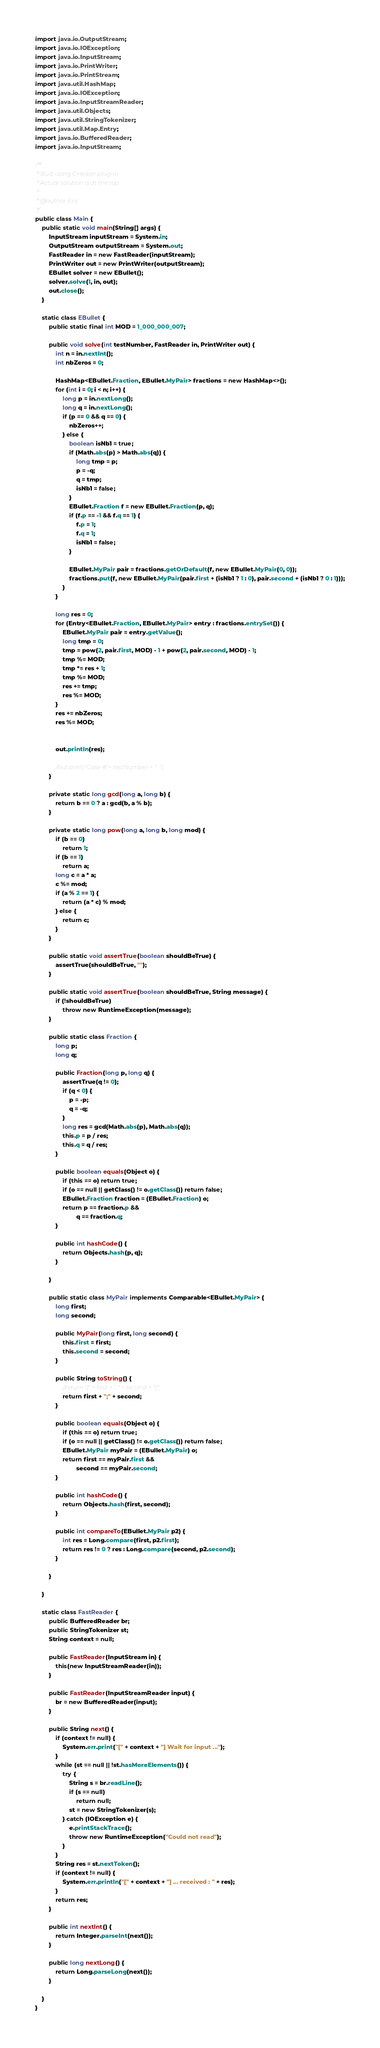<code> <loc_0><loc_0><loc_500><loc_500><_Java_>import java.io.OutputStream;
import java.io.IOException;
import java.io.InputStream;
import java.io.PrintWriter;
import java.io.PrintStream;
import java.util.HashMap;
import java.io.IOException;
import java.io.InputStreamReader;
import java.util.Objects;
import java.util.StringTokenizer;
import java.util.Map.Entry;
import java.io.BufferedReader;
import java.io.InputStream;

/**
 * Built using CHelper plug-in
 * Actual solution is at the top
 *
 * @author Eric
 */
public class Main {
    public static void main(String[] args) {
        InputStream inputStream = System.in;
        OutputStream outputStream = System.out;
        FastReader in = new FastReader(inputStream);
        PrintWriter out = new PrintWriter(outputStream);
        EBullet solver = new EBullet();
        solver.solve(1, in, out);
        out.close();
    }

    static class EBullet {
        public static final int MOD = 1_000_000_007;

        public void solve(int testNumber, FastReader in, PrintWriter out) {
            int n = in.nextInt();
            int nbZeros = 0;

            HashMap<EBullet.Fraction, EBullet.MyPair> fractions = new HashMap<>();
            for (int i = 0; i < n; i++) {
                long p = in.nextLong();
                long q = in.nextLong();
                if (p == 0 && q == 0) {
                    nbZeros++;
                } else {
                    boolean isNb1 = true;
                    if (Math.abs(p) > Math.abs(q)) {
                        long tmp = p;
                        p = -q;
                        q = tmp;
                        isNb1 = false;
                    }
                    EBullet.Fraction f = new EBullet.Fraction(p, q);
                    if (f.p == -1 && f.q == 1) {
                        f.p = 1;
                        f.q = 1;
                        isNb1 = false;
                    }

                    EBullet.MyPair pair = fractions.getOrDefault(f, new EBullet.MyPair(0, 0));
                    fractions.put(f, new EBullet.MyPair(pair.first + (isNb1 ? 1 : 0), pair.second + (isNb1 ? 0 : 1)));
                }
            }

            long res = 0;
            for (Entry<EBullet.Fraction, EBullet.MyPair> entry : fractions.entrySet()) {
                EBullet.MyPair pair = entry.getValue();
                long tmp = 0;
                tmp = pow(2, pair.first, MOD) - 1 + pow(2, pair.second, MOD) - 1;
                tmp %= MOD;
                tmp *= res + 1;
                tmp %= MOD;
                res += tmp;
                res %= MOD;
            }
            res += nbZeros;
            res %= MOD;


            out.println(res);

            //out.print("Case #"+ testNumber + ": ");
        }

        private static long gcd(long a, long b) {
            return b == 0 ? a : gcd(b, a % b);
        }

        private static long pow(long a, long b, long mod) {
            if (b == 0)
                return 1;
            if (b == 1)
                return a;
            long c = a * a;
            c %= mod;
            if (a % 2 == 1) {
                return (a * c) % mod;
            } else {
                return c;
            }
        }

        public static void assertTrue(boolean shouldBeTrue) {
            assertTrue(shouldBeTrue, "");
        }

        public static void assertTrue(boolean shouldBeTrue, String message) {
            if (!shouldBeTrue)
                throw new RuntimeException(message);
        }

        public static class Fraction {
            long p;
            long q;

            public Fraction(long p, long q) {
                assertTrue(q != 0);
                if (q < 0) {
                    p = -p;
                    q = -q;
                }
                long res = gcd(Math.abs(p), Math.abs(q));
                this.p = p / res;
                this.q = q / res;
            }

            public boolean equals(Object o) {
                if (this == o) return true;
                if (o == null || getClass() != o.getClass()) return false;
                EBullet.Fraction fraction = (EBullet.Fraction) o;
                return p == fraction.p &&
                        q == fraction.q;
            }

            public int hashCode() {
                return Objects.hash(p, q);
            }

        }

        public static class MyPair implements Comparable<EBullet.MyPair> {
            long first;
            long second;

            public MyPair(long first, long second) {
                this.first = first;
                this.second = second;
            }

            public String toString() {
                //return "[" + first + ", " + second + "]";
                return first + ";" + second;
            }

            public boolean equals(Object o) {
                if (this == o) return true;
                if (o == null || getClass() != o.getClass()) return false;
                EBullet.MyPair myPair = (EBullet.MyPair) o;
                return first == myPair.first &&
                        second == myPair.second;
            }

            public int hashCode() {
                return Objects.hash(first, second);
            }

            public int compareTo(EBullet.MyPair p2) {
                int res = Long.compare(first, p2.first);
                return res != 0 ? res : Long.compare(second, p2.second);
            }

        }

    }

    static class FastReader {
        public BufferedReader br;
        public StringTokenizer st;
        String context = null;

        public FastReader(InputStream in) {
            this(new InputStreamReader(in));
        }

        public FastReader(InputStreamReader input) {
            br = new BufferedReader(input);
        }

        public String next() {
            if (context != null) {
                System.err.print("[" + context + "] Wait for input ...");
            }
            while (st == null || !st.hasMoreElements()) {
                try {
                    String s = br.readLine();
                    if (s == null)
                        return null;
                    st = new StringTokenizer(s);
                } catch (IOException e) {
                    e.printStackTrace();
                    throw new RuntimeException("Could not read");
                }
            }
            String res = st.nextToken();
            if (context != null) {
                System.err.println("[" + context + "] ... received : " + res);
            }
            return res;
        }

        public int nextInt() {
            return Integer.parseInt(next());
        }

        public long nextLong() {
            return Long.parseLong(next());
        }

    }
}

</code> 